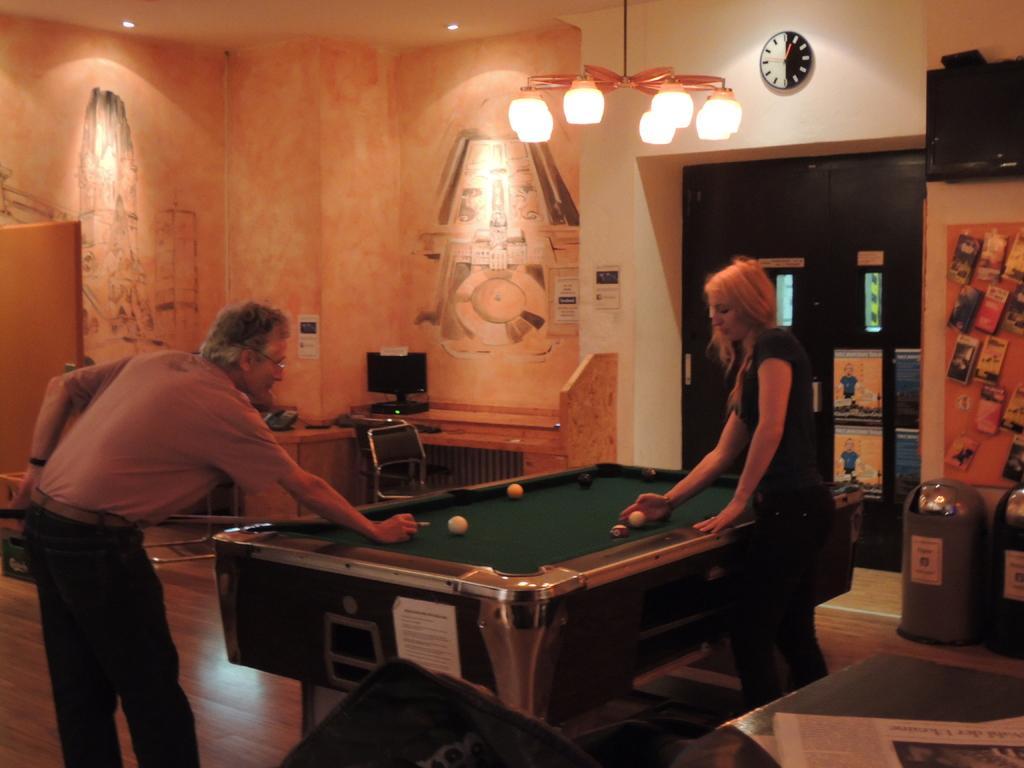Can you describe this image briefly? In this image i can see there is a man, a woman are standing on the floor. I can also see there is a snooker table, a chandelier and a clock on the wall. 